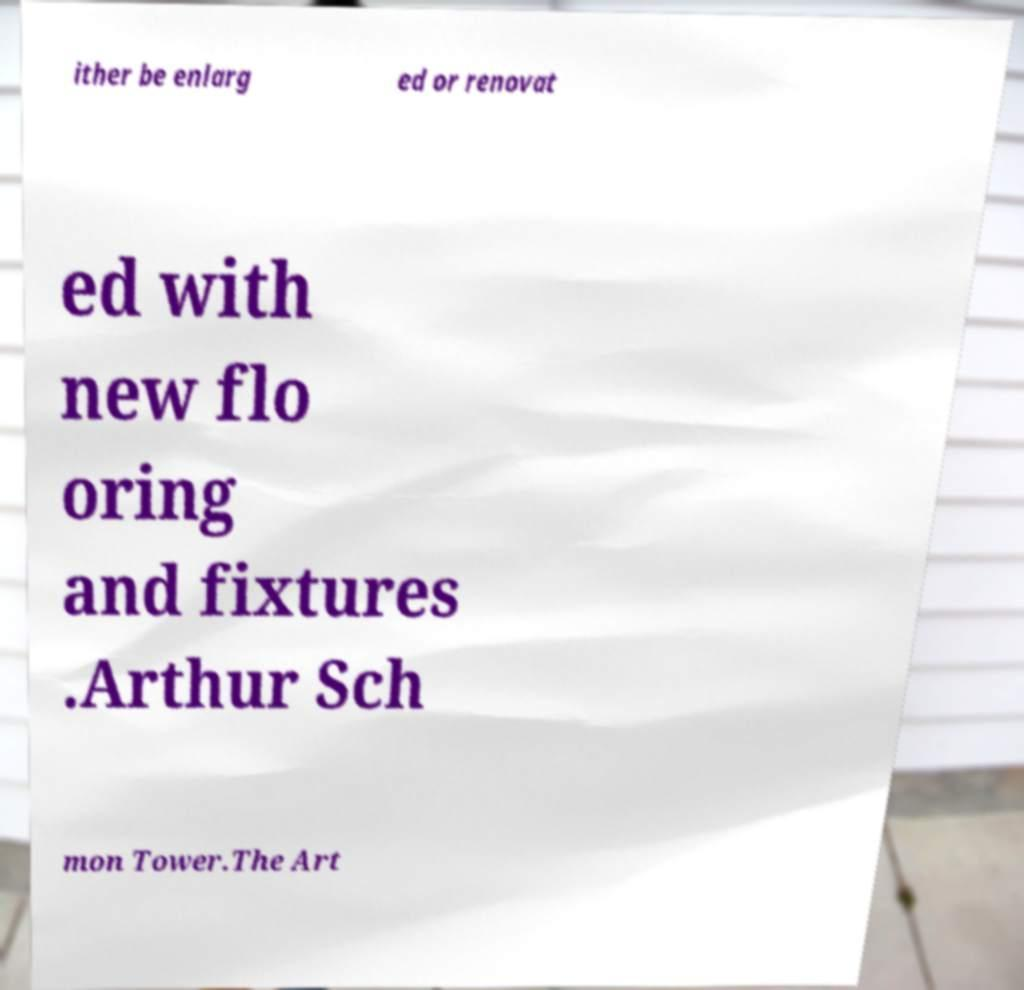Please read and relay the text visible in this image. What does it say? ither be enlarg ed or renovat ed with new flo oring and fixtures .Arthur Sch mon Tower.The Art 